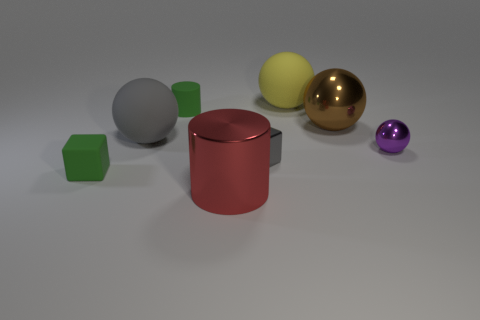Is the number of shiny cylinders to the left of the gray matte ball less than the number of spheres behind the big brown thing?
Offer a terse response. Yes. How many big cyan balls are there?
Your response must be concise. 0. Are there any other things that are the same material as the tiny gray thing?
Offer a terse response. Yes. There is a green object that is the same shape as the large red object; what is it made of?
Give a very brief answer. Rubber. Is the number of small green matte cubes on the left side of the rubber block less than the number of shiny objects?
Your answer should be very brief. Yes. There is a small thing to the right of the yellow matte ball; is its shape the same as the big yellow object?
Your response must be concise. Yes. Is there any other thing of the same color as the tiny cylinder?
Offer a terse response. Yes. The other ball that is made of the same material as the small purple sphere is what size?
Offer a terse response. Large. The small block behind the cube to the left of the large cylinder that is in front of the tiny green rubber block is made of what material?
Ensure brevity in your answer.  Metal. Is the number of green objects less than the number of brown metal cylinders?
Keep it short and to the point. No. 